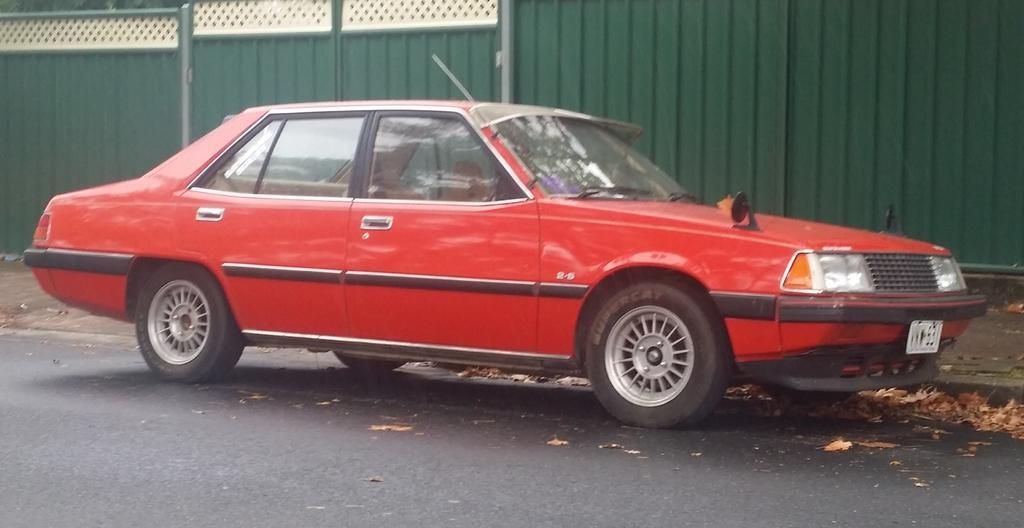In one or two sentences, can you explain what this image depicts? In this picture I can see there is a red color car parked here on the left side of the road and there is a green color wall in the backdrop and also there are some dry leaves here on the floor. 